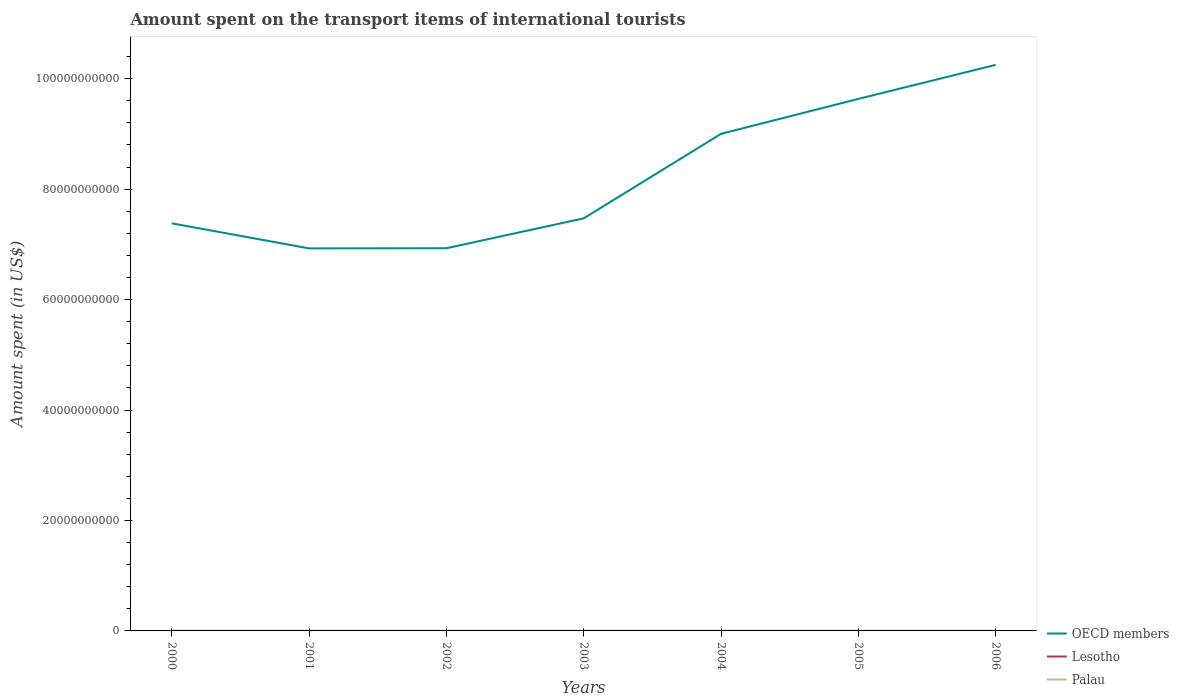Does the line corresponding to OECD members intersect with the line corresponding to Palau?
Ensure brevity in your answer.  No. Is the number of lines equal to the number of legend labels?
Provide a short and direct response. Yes. Across all years, what is the maximum amount spent on the transport items of international tourists in Palau?
Give a very brief answer. 5.20e+06. In which year was the amount spent on the transport items of international tourists in OECD members maximum?
Offer a very short reply. 2001. What is the total amount spent on the transport items of international tourists in Lesotho in the graph?
Your answer should be compact. -6.00e+06. What is the difference between the highest and the second highest amount spent on the transport items of international tourists in Lesotho?
Ensure brevity in your answer.  7.00e+06. Is the amount spent on the transport items of international tourists in Lesotho strictly greater than the amount spent on the transport items of international tourists in OECD members over the years?
Offer a very short reply. Yes. How many lines are there?
Offer a terse response. 3. How many years are there in the graph?
Offer a very short reply. 7. What is the difference between two consecutive major ticks on the Y-axis?
Your answer should be very brief. 2.00e+1. Are the values on the major ticks of Y-axis written in scientific E-notation?
Provide a short and direct response. No. Does the graph contain any zero values?
Make the answer very short. No. How are the legend labels stacked?
Provide a succinct answer. Vertical. What is the title of the graph?
Your answer should be compact. Amount spent on the transport items of international tourists. What is the label or title of the X-axis?
Provide a succinct answer. Years. What is the label or title of the Y-axis?
Offer a terse response. Amount spent (in US$). What is the Amount spent (in US$) of OECD members in 2000?
Your response must be concise. 7.38e+1. What is the Amount spent (in US$) of Lesotho in 2000?
Make the answer very short. 3.00e+06. What is the Amount spent (in US$) in Palau in 2000?
Provide a short and direct response. 5.20e+06. What is the Amount spent (in US$) in OECD members in 2001?
Provide a short and direct response. 6.93e+1. What is the Amount spent (in US$) in Palau in 2001?
Your response must be concise. 6.70e+06. What is the Amount spent (in US$) of OECD members in 2002?
Provide a succinct answer. 6.93e+1. What is the Amount spent (in US$) in Lesotho in 2002?
Make the answer very short. 2.00e+06. What is the Amount spent (in US$) in Palau in 2002?
Your answer should be compact. 9.60e+06. What is the Amount spent (in US$) of OECD members in 2003?
Provide a succinct answer. 7.47e+1. What is the Amount spent (in US$) of Lesotho in 2003?
Your response must be concise. 4.00e+06. What is the Amount spent (in US$) of Palau in 2003?
Keep it short and to the point. 9.00e+06. What is the Amount spent (in US$) in OECD members in 2004?
Your response must be concise. 9.00e+1. What is the Amount spent (in US$) in Palau in 2004?
Your response must be concise. 9.20e+06. What is the Amount spent (in US$) of OECD members in 2005?
Provide a succinct answer. 9.63e+1. What is the Amount spent (in US$) in Lesotho in 2005?
Keep it short and to the point. 9.00e+06. What is the Amount spent (in US$) of Palau in 2005?
Give a very brief answer. 9.70e+06. What is the Amount spent (in US$) of OECD members in 2006?
Provide a succinct answer. 1.02e+11. What is the Amount spent (in US$) of Palau in 2006?
Ensure brevity in your answer.  9.00e+06. Across all years, what is the maximum Amount spent (in US$) in OECD members?
Offer a terse response. 1.02e+11. Across all years, what is the maximum Amount spent (in US$) of Lesotho?
Offer a very short reply. 9.00e+06. Across all years, what is the maximum Amount spent (in US$) of Palau?
Give a very brief answer. 9.70e+06. Across all years, what is the minimum Amount spent (in US$) in OECD members?
Offer a terse response. 6.93e+1. Across all years, what is the minimum Amount spent (in US$) of Palau?
Your answer should be very brief. 5.20e+06. What is the total Amount spent (in US$) of OECD members in the graph?
Offer a very short reply. 5.76e+11. What is the total Amount spent (in US$) of Lesotho in the graph?
Give a very brief answer. 3.10e+07. What is the total Amount spent (in US$) in Palau in the graph?
Offer a terse response. 5.84e+07. What is the difference between the Amount spent (in US$) in OECD members in 2000 and that in 2001?
Your answer should be compact. 4.53e+09. What is the difference between the Amount spent (in US$) in Lesotho in 2000 and that in 2001?
Offer a very short reply. 0. What is the difference between the Amount spent (in US$) in Palau in 2000 and that in 2001?
Provide a short and direct response. -1.50e+06. What is the difference between the Amount spent (in US$) of OECD members in 2000 and that in 2002?
Provide a succinct answer. 4.51e+09. What is the difference between the Amount spent (in US$) of Lesotho in 2000 and that in 2002?
Ensure brevity in your answer.  1.00e+06. What is the difference between the Amount spent (in US$) in Palau in 2000 and that in 2002?
Give a very brief answer. -4.40e+06. What is the difference between the Amount spent (in US$) of OECD members in 2000 and that in 2003?
Your answer should be very brief. -9.03e+08. What is the difference between the Amount spent (in US$) of Palau in 2000 and that in 2003?
Your response must be concise. -3.80e+06. What is the difference between the Amount spent (in US$) in OECD members in 2000 and that in 2004?
Make the answer very short. -1.62e+1. What is the difference between the Amount spent (in US$) in Lesotho in 2000 and that in 2004?
Provide a succinct answer. -4.00e+06. What is the difference between the Amount spent (in US$) of OECD members in 2000 and that in 2005?
Keep it short and to the point. -2.25e+1. What is the difference between the Amount spent (in US$) of Lesotho in 2000 and that in 2005?
Your response must be concise. -6.00e+06. What is the difference between the Amount spent (in US$) in Palau in 2000 and that in 2005?
Give a very brief answer. -4.50e+06. What is the difference between the Amount spent (in US$) of OECD members in 2000 and that in 2006?
Your response must be concise. -2.87e+1. What is the difference between the Amount spent (in US$) in Palau in 2000 and that in 2006?
Provide a succinct answer. -3.80e+06. What is the difference between the Amount spent (in US$) in OECD members in 2001 and that in 2002?
Give a very brief answer. -2.66e+07. What is the difference between the Amount spent (in US$) of Palau in 2001 and that in 2002?
Provide a succinct answer. -2.90e+06. What is the difference between the Amount spent (in US$) of OECD members in 2001 and that in 2003?
Provide a succinct answer. -5.44e+09. What is the difference between the Amount spent (in US$) in Lesotho in 2001 and that in 2003?
Keep it short and to the point. -1.00e+06. What is the difference between the Amount spent (in US$) in Palau in 2001 and that in 2003?
Your answer should be very brief. -2.30e+06. What is the difference between the Amount spent (in US$) of OECD members in 2001 and that in 2004?
Give a very brief answer. -2.07e+1. What is the difference between the Amount spent (in US$) in Lesotho in 2001 and that in 2004?
Provide a succinct answer. -4.00e+06. What is the difference between the Amount spent (in US$) of Palau in 2001 and that in 2004?
Ensure brevity in your answer.  -2.50e+06. What is the difference between the Amount spent (in US$) of OECD members in 2001 and that in 2005?
Your answer should be compact. -2.71e+1. What is the difference between the Amount spent (in US$) in Lesotho in 2001 and that in 2005?
Your answer should be compact. -6.00e+06. What is the difference between the Amount spent (in US$) of OECD members in 2001 and that in 2006?
Give a very brief answer. -3.32e+1. What is the difference between the Amount spent (in US$) in Lesotho in 2001 and that in 2006?
Your response must be concise. 0. What is the difference between the Amount spent (in US$) of Palau in 2001 and that in 2006?
Your response must be concise. -2.30e+06. What is the difference between the Amount spent (in US$) in OECD members in 2002 and that in 2003?
Provide a succinct answer. -5.41e+09. What is the difference between the Amount spent (in US$) of Lesotho in 2002 and that in 2003?
Your answer should be compact. -2.00e+06. What is the difference between the Amount spent (in US$) in OECD members in 2002 and that in 2004?
Your answer should be compact. -2.07e+1. What is the difference between the Amount spent (in US$) in Lesotho in 2002 and that in 2004?
Your response must be concise. -5.00e+06. What is the difference between the Amount spent (in US$) of OECD members in 2002 and that in 2005?
Provide a short and direct response. -2.70e+1. What is the difference between the Amount spent (in US$) in Lesotho in 2002 and that in 2005?
Make the answer very short. -7.00e+06. What is the difference between the Amount spent (in US$) in Palau in 2002 and that in 2005?
Your response must be concise. -1.00e+05. What is the difference between the Amount spent (in US$) in OECD members in 2002 and that in 2006?
Your response must be concise. -3.32e+1. What is the difference between the Amount spent (in US$) in Palau in 2002 and that in 2006?
Ensure brevity in your answer.  6.00e+05. What is the difference between the Amount spent (in US$) in OECD members in 2003 and that in 2004?
Your response must be concise. -1.53e+1. What is the difference between the Amount spent (in US$) in Palau in 2003 and that in 2004?
Offer a very short reply. -2.00e+05. What is the difference between the Amount spent (in US$) of OECD members in 2003 and that in 2005?
Offer a very short reply. -2.16e+1. What is the difference between the Amount spent (in US$) in Lesotho in 2003 and that in 2005?
Offer a terse response. -5.00e+06. What is the difference between the Amount spent (in US$) of Palau in 2003 and that in 2005?
Keep it short and to the point. -7.00e+05. What is the difference between the Amount spent (in US$) of OECD members in 2003 and that in 2006?
Your response must be concise. -2.78e+1. What is the difference between the Amount spent (in US$) in Lesotho in 2003 and that in 2006?
Provide a short and direct response. 1.00e+06. What is the difference between the Amount spent (in US$) in Palau in 2003 and that in 2006?
Give a very brief answer. 0. What is the difference between the Amount spent (in US$) in OECD members in 2004 and that in 2005?
Your answer should be very brief. -6.32e+09. What is the difference between the Amount spent (in US$) of Lesotho in 2004 and that in 2005?
Make the answer very short. -2.00e+06. What is the difference between the Amount spent (in US$) in Palau in 2004 and that in 2005?
Give a very brief answer. -5.00e+05. What is the difference between the Amount spent (in US$) in OECD members in 2004 and that in 2006?
Offer a terse response. -1.25e+1. What is the difference between the Amount spent (in US$) of OECD members in 2005 and that in 2006?
Give a very brief answer. -6.16e+09. What is the difference between the Amount spent (in US$) in Lesotho in 2005 and that in 2006?
Provide a succinct answer. 6.00e+06. What is the difference between the Amount spent (in US$) in OECD members in 2000 and the Amount spent (in US$) in Lesotho in 2001?
Provide a short and direct response. 7.38e+1. What is the difference between the Amount spent (in US$) in OECD members in 2000 and the Amount spent (in US$) in Palau in 2001?
Keep it short and to the point. 7.38e+1. What is the difference between the Amount spent (in US$) of Lesotho in 2000 and the Amount spent (in US$) of Palau in 2001?
Offer a very short reply. -3.70e+06. What is the difference between the Amount spent (in US$) of OECD members in 2000 and the Amount spent (in US$) of Lesotho in 2002?
Your answer should be very brief. 7.38e+1. What is the difference between the Amount spent (in US$) in OECD members in 2000 and the Amount spent (in US$) in Palau in 2002?
Your answer should be compact. 7.38e+1. What is the difference between the Amount spent (in US$) of Lesotho in 2000 and the Amount spent (in US$) of Palau in 2002?
Give a very brief answer. -6.60e+06. What is the difference between the Amount spent (in US$) in OECD members in 2000 and the Amount spent (in US$) in Lesotho in 2003?
Provide a short and direct response. 7.38e+1. What is the difference between the Amount spent (in US$) of OECD members in 2000 and the Amount spent (in US$) of Palau in 2003?
Offer a terse response. 7.38e+1. What is the difference between the Amount spent (in US$) in Lesotho in 2000 and the Amount spent (in US$) in Palau in 2003?
Provide a short and direct response. -6.00e+06. What is the difference between the Amount spent (in US$) of OECD members in 2000 and the Amount spent (in US$) of Lesotho in 2004?
Give a very brief answer. 7.38e+1. What is the difference between the Amount spent (in US$) of OECD members in 2000 and the Amount spent (in US$) of Palau in 2004?
Your answer should be very brief. 7.38e+1. What is the difference between the Amount spent (in US$) of Lesotho in 2000 and the Amount spent (in US$) of Palau in 2004?
Your response must be concise. -6.20e+06. What is the difference between the Amount spent (in US$) of OECD members in 2000 and the Amount spent (in US$) of Lesotho in 2005?
Ensure brevity in your answer.  7.38e+1. What is the difference between the Amount spent (in US$) of OECD members in 2000 and the Amount spent (in US$) of Palau in 2005?
Offer a very short reply. 7.38e+1. What is the difference between the Amount spent (in US$) of Lesotho in 2000 and the Amount spent (in US$) of Palau in 2005?
Ensure brevity in your answer.  -6.70e+06. What is the difference between the Amount spent (in US$) of OECD members in 2000 and the Amount spent (in US$) of Lesotho in 2006?
Ensure brevity in your answer.  7.38e+1. What is the difference between the Amount spent (in US$) in OECD members in 2000 and the Amount spent (in US$) in Palau in 2006?
Offer a very short reply. 7.38e+1. What is the difference between the Amount spent (in US$) of Lesotho in 2000 and the Amount spent (in US$) of Palau in 2006?
Offer a terse response. -6.00e+06. What is the difference between the Amount spent (in US$) in OECD members in 2001 and the Amount spent (in US$) in Lesotho in 2002?
Your response must be concise. 6.93e+1. What is the difference between the Amount spent (in US$) in OECD members in 2001 and the Amount spent (in US$) in Palau in 2002?
Your answer should be compact. 6.93e+1. What is the difference between the Amount spent (in US$) in Lesotho in 2001 and the Amount spent (in US$) in Palau in 2002?
Give a very brief answer. -6.60e+06. What is the difference between the Amount spent (in US$) of OECD members in 2001 and the Amount spent (in US$) of Lesotho in 2003?
Give a very brief answer. 6.93e+1. What is the difference between the Amount spent (in US$) of OECD members in 2001 and the Amount spent (in US$) of Palau in 2003?
Your answer should be very brief. 6.93e+1. What is the difference between the Amount spent (in US$) of Lesotho in 2001 and the Amount spent (in US$) of Palau in 2003?
Ensure brevity in your answer.  -6.00e+06. What is the difference between the Amount spent (in US$) of OECD members in 2001 and the Amount spent (in US$) of Lesotho in 2004?
Keep it short and to the point. 6.93e+1. What is the difference between the Amount spent (in US$) in OECD members in 2001 and the Amount spent (in US$) in Palau in 2004?
Ensure brevity in your answer.  6.93e+1. What is the difference between the Amount spent (in US$) in Lesotho in 2001 and the Amount spent (in US$) in Palau in 2004?
Your response must be concise. -6.20e+06. What is the difference between the Amount spent (in US$) of OECD members in 2001 and the Amount spent (in US$) of Lesotho in 2005?
Give a very brief answer. 6.93e+1. What is the difference between the Amount spent (in US$) of OECD members in 2001 and the Amount spent (in US$) of Palau in 2005?
Make the answer very short. 6.93e+1. What is the difference between the Amount spent (in US$) of Lesotho in 2001 and the Amount spent (in US$) of Palau in 2005?
Your response must be concise. -6.70e+06. What is the difference between the Amount spent (in US$) in OECD members in 2001 and the Amount spent (in US$) in Lesotho in 2006?
Offer a very short reply. 6.93e+1. What is the difference between the Amount spent (in US$) in OECD members in 2001 and the Amount spent (in US$) in Palau in 2006?
Offer a very short reply. 6.93e+1. What is the difference between the Amount spent (in US$) of Lesotho in 2001 and the Amount spent (in US$) of Palau in 2006?
Keep it short and to the point. -6.00e+06. What is the difference between the Amount spent (in US$) of OECD members in 2002 and the Amount spent (in US$) of Lesotho in 2003?
Give a very brief answer. 6.93e+1. What is the difference between the Amount spent (in US$) of OECD members in 2002 and the Amount spent (in US$) of Palau in 2003?
Your answer should be compact. 6.93e+1. What is the difference between the Amount spent (in US$) of Lesotho in 2002 and the Amount spent (in US$) of Palau in 2003?
Your response must be concise. -7.00e+06. What is the difference between the Amount spent (in US$) of OECD members in 2002 and the Amount spent (in US$) of Lesotho in 2004?
Keep it short and to the point. 6.93e+1. What is the difference between the Amount spent (in US$) in OECD members in 2002 and the Amount spent (in US$) in Palau in 2004?
Keep it short and to the point. 6.93e+1. What is the difference between the Amount spent (in US$) in Lesotho in 2002 and the Amount spent (in US$) in Palau in 2004?
Keep it short and to the point. -7.20e+06. What is the difference between the Amount spent (in US$) in OECD members in 2002 and the Amount spent (in US$) in Lesotho in 2005?
Offer a terse response. 6.93e+1. What is the difference between the Amount spent (in US$) of OECD members in 2002 and the Amount spent (in US$) of Palau in 2005?
Your answer should be compact. 6.93e+1. What is the difference between the Amount spent (in US$) of Lesotho in 2002 and the Amount spent (in US$) of Palau in 2005?
Your answer should be very brief. -7.70e+06. What is the difference between the Amount spent (in US$) in OECD members in 2002 and the Amount spent (in US$) in Lesotho in 2006?
Offer a very short reply. 6.93e+1. What is the difference between the Amount spent (in US$) in OECD members in 2002 and the Amount spent (in US$) in Palau in 2006?
Keep it short and to the point. 6.93e+1. What is the difference between the Amount spent (in US$) of Lesotho in 2002 and the Amount spent (in US$) of Palau in 2006?
Your response must be concise. -7.00e+06. What is the difference between the Amount spent (in US$) in OECD members in 2003 and the Amount spent (in US$) in Lesotho in 2004?
Make the answer very short. 7.47e+1. What is the difference between the Amount spent (in US$) in OECD members in 2003 and the Amount spent (in US$) in Palau in 2004?
Ensure brevity in your answer.  7.47e+1. What is the difference between the Amount spent (in US$) of Lesotho in 2003 and the Amount spent (in US$) of Palau in 2004?
Your answer should be very brief. -5.20e+06. What is the difference between the Amount spent (in US$) in OECD members in 2003 and the Amount spent (in US$) in Lesotho in 2005?
Make the answer very short. 7.47e+1. What is the difference between the Amount spent (in US$) of OECD members in 2003 and the Amount spent (in US$) of Palau in 2005?
Your answer should be compact. 7.47e+1. What is the difference between the Amount spent (in US$) of Lesotho in 2003 and the Amount spent (in US$) of Palau in 2005?
Offer a very short reply. -5.70e+06. What is the difference between the Amount spent (in US$) of OECD members in 2003 and the Amount spent (in US$) of Lesotho in 2006?
Make the answer very short. 7.47e+1. What is the difference between the Amount spent (in US$) in OECD members in 2003 and the Amount spent (in US$) in Palau in 2006?
Your response must be concise. 7.47e+1. What is the difference between the Amount spent (in US$) in Lesotho in 2003 and the Amount spent (in US$) in Palau in 2006?
Give a very brief answer. -5.00e+06. What is the difference between the Amount spent (in US$) in OECD members in 2004 and the Amount spent (in US$) in Lesotho in 2005?
Your response must be concise. 9.00e+1. What is the difference between the Amount spent (in US$) in OECD members in 2004 and the Amount spent (in US$) in Palau in 2005?
Make the answer very short. 9.00e+1. What is the difference between the Amount spent (in US$) in Lesotho in 2004 and the Amount spent (in US$) in Palau in 2005?
Give a very brief answer. -2.70e+06. What is the difference between the Amount spent (in US$) in OECD members in 2004 and the Amount spent (in US$) in Lesotho in 2006?
Offer a very short reply. 9.00e+1. What is the difference between the Amount spent (in US$) in OECD members in 2004 and the Amount spent (in US$) in Palau in 2006?
Provide a short and direct response. 9.00e+1. What is the difference between the Amount spent (in US$) of OECD members in 2005 and the Amount spent (in US$) of Lesotho in 2006?
Give a very brief answer. 9.63e+1. What is the difference between the Amount spent (in US$) in OECD members in 2005 and the Amount spent (in US$) in Palau in 2006?
Provide a succinct answer. 9.63e+1. What is the average Amount spent (in US$) in OECD members per year?
Give a very brief answer. 8.23e+1. What is the average Amount spent (in US$) of Lesotho per year?
Ensure brevity in your answer.  4.43e+06. What is the average Amount spent (in US$) in Palau per year?
Offer a terse response. 8.34e+06. In the year 2000, what is the difference between the Amount spent (in US$) in OECD members and Amount spent (in US$) in Lesotho?
Your answer should be very brief. 7.38e+1. In the year 2000, what is the difference between the Amount spent (in US$) of OECD members and Amount spent (in US$) of Palau?
Provide a short and direct response. 7.38e+1. In the year 2000, what is the difference between the Amount spent (in US$) in Lesotho and Amount spent (in US$) in Palau?
Provide a short and direct response. -2.20e+06. In the year 2001, what is the difference between the Amount spent (in US$) of OECD members and Amount spent (in US$) of Lesotho?
Give a very brief answer. 6.93e+1. In the year 2001, what is the difference between the Amount spent (in US$) in OECD members and Amount spent (in US$) in Palau?
Give a very brief answer. 6.93e+1. In the year 2001, what is the difference between the Amount spent (in US$) in Lesotho and Amount spent (in US$) in Palau?
Ensure brevity in your answer.  -3.70e+06. In the year 2002, what is the difference between the Amount spent (in US$) of OECD members and Amount spent (in US$) of Lesotho?
Ensure brevity in your answer.  6.93e+1. In the year 2002, what is the difference between the Amount spent (in US$) in OECD members and Amount spent (in US$) in Palau?
Make the answer very short. 6.93e+1. In the year 2002, what is the difference between the Amount spent (in US$) of Lesotho and Amount spent (in US$) of Palau?
Your response must be concise. -7.60e+06. In the year 2003, what is the difference between the Amount spent (in US$) of OECD members and Amount spent (in US$) of Lesotho?
Provide a short and direct response. 7.47e+1. In the year 2003, what is the difference between the Amount spent (in US$) in OECD members and Amount spent (in US$) in Palau?
Your response must be concise. 7.47e+1. In the year 2003, what is the difference between the Amount spent (in US$) in Lesotho and Amount spent (in US$) in Palau?
Offer a very short reply. -5.00e+06. In the year 2004, what is the difference between the Amount spent (in US$) of OECD members and Amount spent (in US$) of Lesotho?
Provide a succinct answer. 9.00e+1. In the year 2004, what is the difference between the Amount spent (in US$) in OECD members and Amount spent (in US$) in Palau?
Ensure brevity in your answer.  9.00e+1. In the year 2004, what is the difference between the Amount spent (in US$) in Lesotho and Amount spent (in US$) in Palau?
Your response must be concise. -2.20e+06. In the year 2005, what is the difference between the Amount spent (in US$) in OECD members and Amount spent (in US$) in Lesotho?
Make the answer very short. 9.63e+1. In the year 2005, what is the difference between the Amount spent (in US$) in OECD members and Amount spent (in US$) in Palau?
Ensure brevity in your answer.  9.63e+1. In the year 2005, what is the difference between the Amount spent (in US$) of Lesotho and Amount spent (in US$) of Palau?
Your answer should be compact. -7.00e+05. In the year 2006, what is the difference between the Amount spent (in US$) of OECD members and Amount spent (in US$) of Lesotho?
Provide a succinct answer. 1.02e+11. In the year 2006, what is the difference between the Amount spent (in US$) of OECD members and Amount spent (in US$) of Palau?
Make the answer very short. 1.02e+11. In the year 2006, what is the difference between the Amount spent (in US$) in Lesotho and Amount spent (in US$) in Palau?
Your response must be concise. -6.00e+06. What is the ratio of the Amount spent (in US$) in OECD members in 2000 to that in 2001?
Your response must be concise. 1.07. What is the ratio of the Amount spent (in US$) in Lesotho in 2000 to that in 2001?
Keep it short and to the point. 1. What is the ratio of the Amount spent (in US$) of Palau in 2000 to that in 2001?
Keep it short and to the point. 0.78. What is the ratio of the Amount spent (in US$) of OECD members in 2000 to that in 2002?
Make the answer very short. 1.06. What is the ratio of the Amount spent (in US$) of Lesotho in 2000 to that in 2002?
Provide a succinct answer. 1.5. What is the ratio of the Amount spent (in US$) of Palau in 2000 to that in 2002?
Provide a succinct answer. 0.54. What is the ratio of the Amount spent (in US$) in OECD members in 2000 to that in 2003?
Your answer should be compact. 0.99. What is the ratio of the Amount spent (in US$) of Palau in 2000 to that in 2003?
Provide a succinct answer. 0.58. What is the ratio of the Amount spent (in US$) in OECD members in 2000 to that in 2004?
Give a very brief answer. 0.82. What is the ratio of the Amount spent (in US$) in Lesotho in 2000 to that in 2004?
Your answer should be compact. 0.43. What is the ratio of the Amount spent (in US$) in Palau in 2000 to that in 2004?
Offer a very short reply. 0.57. What is the ratio of the Amount spent (in US$) of OECD members in 2000 to that in 2005?
Provide a short and direct response. 0.77. What is the ratio of the Amount spent (in US$) in Palau in 2000 to that in 2005?
Provide a short and direct response. 0.54. What is the ratio of the Amount spent (in US$) in OECD members in 2000 to that in 2006?
Ensure brevity in your answer.  0.72. What is the ratio of the Amount spent (in US$) in Lesotho in 2000 to that in 2006?
Make the answer very short. 1. What is the ratio of the Amount spent (in US$) of Palau in 2000 to that in 2006?
Offer a terse response. 0.58. What is the ratio of the Amount spent (in US$) in Lesotho in 2001 to that in 2002?
Your response must be concise. 1.5. What is the ratio of the Amount spent (in US$) of Palau in 2001 to that in 2002?
Keep it short and to the point. 0.7. What is the ratio of the Amount spent (in US$) in OECD members in 2001 to that in 2003?
Keep it short and to the point. 0.93. What is the ratio of the Amount spent (in US$) of Palau in 2001 to that in 2003?
Keep it short and to the point. 0.74. What is the ratio of the Amount spent (in US$) in OECD members in 2001 to that in 2004?
Keep it short and to the point. 0.77. What is the ratio of the Amount spent (in US$) of Lesotho in 2001 to that in 2004?
Your answer should be compact. 0.43. What is the ratio of the Amount spent (in US$) in Palau in 2001 to that in 2004?
Keep it short and to the point. 0.73. What is the ratio of the Amount spent (in US$) of OECD members in 2001 to that in 2005?
Provide a succinct answer. 0.72. What is the ratio of the Amount spent (in US$) in Palau in 2001 to that in 2005?
Give a very brief answer. 0.69. What is the ratio of the Amount spent (in US$) in OECD members in 2001 to that in 2006?
Offer a terse response. 0.68. What is the ratio of the Amount spent (in US$) of Palau in 2001 to that in 2006?
Provide a succinct answer. 0.74. What is the ratio of the Amount spent (in US$) in OECD members in 2002 to that in 2003?
Your response must be concise. 0.93. What is the ratio of the Amount spent (in US$) of Lesotho in 2002 to that in 2003?
Provide a short and direct response. 0.5. What is the ratio of the Amount spent (in US$) in Palau in 2002 to that in 2003?
Your answer should be compact. 1.07. What is the ratio of the Amount spent (in US$) of OECD members in 2002 to that in 2004?
Give a very brief answer. 0.77. What is the ratio of the Amount spent (in US$) of Lesotho in 2002 to that in 2004?
Ensure brevity in your answer.  0.29. What is the ratio of the Amount spent (in US$) of Palau in 2002 to that in 2004?
Ensure brevity in your answer.  1.04. What is the ratio of the Amount spent (in US$) in OECD members in 2002 to that in 2005?
Offer a terse response. 0.72. What is the ratio of the Amount spent (in US$) in Lesotho in 2002 to that in 2005?
Provide a short and direct response. 0.22. What is the ratio of the Amount spent (in US$) of OECD members in 2002 to that in 2006?
Make the answer very short. 0.68. What is the ratio of the Amount spent (in US$) in Palau in 2002 to that in 2006?
Offer a very short reply. 1.07. What is the ratio of the Amount spent (in US$) of OECD members in 2003 to that in 2004?
Your response must be concise. 0.83. What is the ratio of the Amount spent (in US$) of Palau in 2003 to that in 2004?
Offer a very short reply. 0.98. What is the ratio of the Amount spent (in US$) of OECD members in 2003 to that in 2005?
Give a very brief answer. 0.78. What is the ratio of the Amount spent (in US$) in Lesotho in 2003 to that in 2005?
Your answer should be very brief. 0.44. What is the ratio of the Amount spent (in US$) of Palau in 2003 to that in 2005?
Offer a terse response. 0.93. What is the ratio of the Amount spent (in US$) of OECD members in 2003 to that in 2006?
Your answer should be compact. 0.73. What is the ratio of the Amount spent (in US$) in OECD members in 2004 to that in 2005?
Make the answer very short. 0.93. What is the ratio of the Amount spent (in US$) of Palau in 2004 to that in 2005?
Make the answer very short. 0.95. What is the ratio of the Amount spent (in US$) of OECD members in 2004 to that in 2006?
Your response must be concise. 0.88. What is the ratio of the Amount spent (in US$) of Lesotho in 2004 to that in 2006?
Provide a succinct answer. 2.33. What is the ratio of the Amount spent (in US$) of Palau in 2004 to that in 2006?
Provide a short and direct response. 1.02. What is the ratio of the Amount spent (in US$) in OECD members in 2005 to that in 2006?
Make the answer very short. 0.94. What is the ratio of the Amount spent (in US$) of Palau in 2005 to that in 2006?
Your answer should be very brief. 1.08. What is the difference between the highest and the second highest Amount spent (in US$) in OECD members?
Make the answer very short. 6.16e+09. What is the difference between the highest and the second highest Amount spent (in US$) in Lesotho?
Your answer should be very brief. 2.00e+06. What is the difference between the highest and the lowest Amount spent (in US$) of OECD members?
Provide a short and direct response. 3.32e+1. What is the difference between the highest and the lowest Amount spent (in US$) of Palau?
Provide a succinct answer. 4.50e+06. 